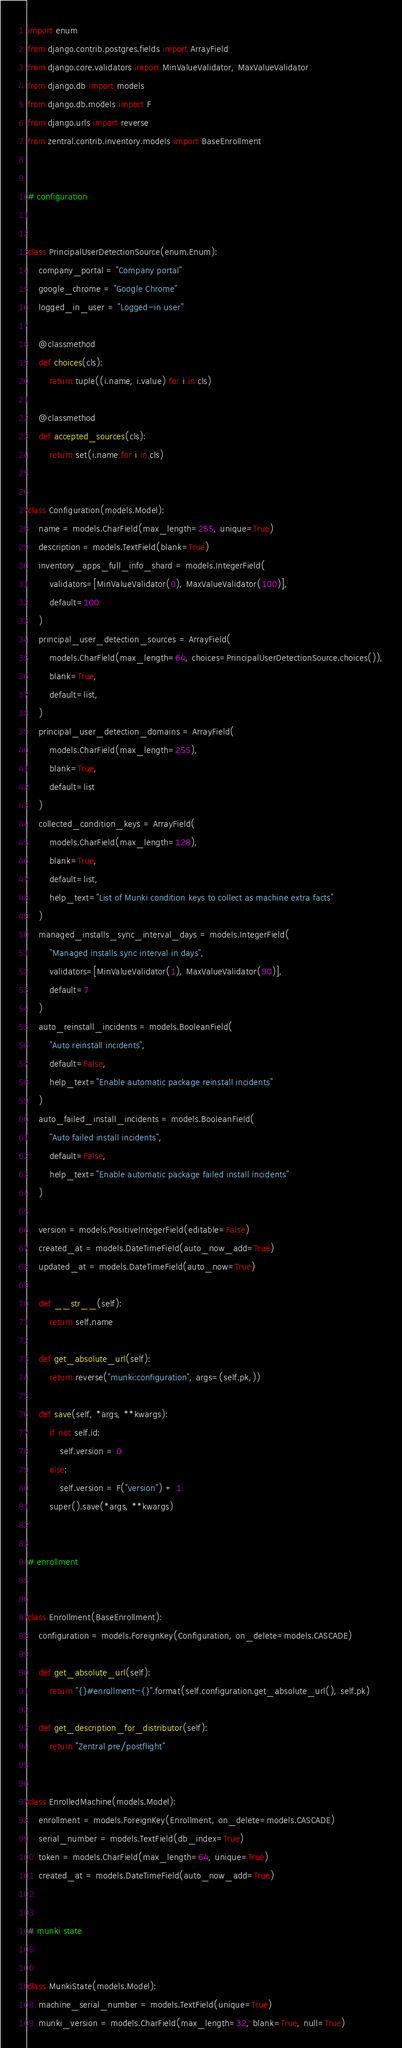Convert code to text. <code><loc_0><loc_0><loc_500><loc_500><_Python_>import enum
from django.contrib.postgres.fields import ArrayField
from django.core.validators import MinValueValidator, MaxValueValidator
from django.db import models
from django.db.models import F
from django.urls import reverse
from zentral.contrib.inventory.models import BaseEnrollment


# configuration


class PrincipalUserDetectionSource(enum.Enum):
    company_portal = "Company portal"
    google_chrome = "Google Chrome"
    logged_in_user = "Logged-in user"

    @classmethod
    def choices(cls):
        return tuple((i.name, i.value) for i in cls)

    @classmethod
    def accepted_sources(cls):
        return set(i.name for i in cls)


class Configuration(models.Model):
    name = models.CharField(max_length=255, unique=True)
    description = models.TextField(blank=True)
    inventory_apps_full_info_shard = models.IntegerField(
        validators=[MinValueValidator(0), MaxValueValidator(100)],
        default=100
    )
    principal_user_detection_sources = ArrayField(
        models.CharField(max_length=64, choices=PrincipalUserDetectionSource.choices()),
        blank=True,
        default=list,
    )
    principal_user_detection_domains = ArrayField(
        models.CharField(max_length=255),
        blank=True,
        default=list
    )
    collected_condition_keys = ArrayField(
        models.CharField(max_length=128),
        blank=True,
        default=list,
        help_text="List of Munki condition keys to collect as machine extra facts"
    )
    managed_installs_sync_interval_days = models.IntegerField(
        "Managed installs sync interval in days",
        validators=[MinValueValidator(1), MaxValueValidator(90)],
        default=7
    )
    auto_reinstall_incidents = models.BooleanField(
        "Auto reinstall incidents",
        default=False,
        help_text="Enable automatic package reinstall incidents"
    )
    auto_failed_install_incidents = models.BooleanField(
        "Auto failed install incidents",
        default=False,
        help_text="Enable automatic package failed install incidents"
    )

    version = models.PositiveIntegerField(editable=False)
    created_at = models.DateTimeField(auto_now_add=True)
    updated_at = models.DateTimeField(auto_now=True)

    def __str__(self):
        return self.name

    def get_absolute_url(self):
        return reverse("munki:configuration", args=(self.pk,))

    def save(self, *args, **kwargs):
        if not self.id:
            self.version = 0
        else:
            self.version = F("version") + 1
        super().save(*args, **kwargs)


# enrollment


class Enrollment(BaseEnrollment):
    configuration = models.ForeignKey(Configuration, on_delete=models.CASCADE)

    def get_absolute_url(self):
        return "{}#enrollment-{}".format(self.configuration.get_absolute_url(), self.pk)

    def get_description_for_distributor(self):
        return "Zentral pre/postflight"


class EnrolledMachine(models.Model):
    enrollment = models.ForeignKey(Enrollment, on_delete=models.CASCADE)
    serial_number = models.TextField(db_index=True)
    token = models.CharField(max_length=64, unique=True)
    created_at = models.DateTimeField(auto_now_add=True)


# munki state


class MunkiState(models.Model):
    machine_serial_number = models.TextField(unique=True)
    munki_version = models.CharField(max_length=32, blank=True, null=True)</code> 